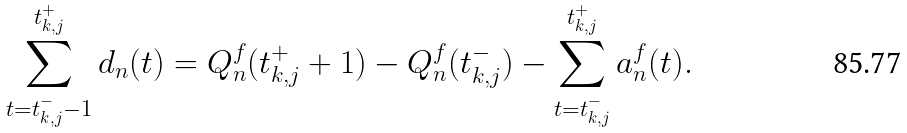Convert formula to latex. <formula><loc_0><loc_0><loc_500><loc_500>\sum _ { t = t _ { k , j } ^ { - } - 1 } ^ { t _ { k , j } ^ { + } } d _ { n } ( t ) = Q _ { n } ^ { f } ( t _ { k , j } ^ { + } + 1 ) - Q _ { n } ^ { f } ( t _ { k , j } ^ { - } ) - \sum _ { t = t _ { k , j } ^ { - } } ^ { t _ { k , j } ^ { + } } a _ { n } ^ { f } ( t ) .</formula> 